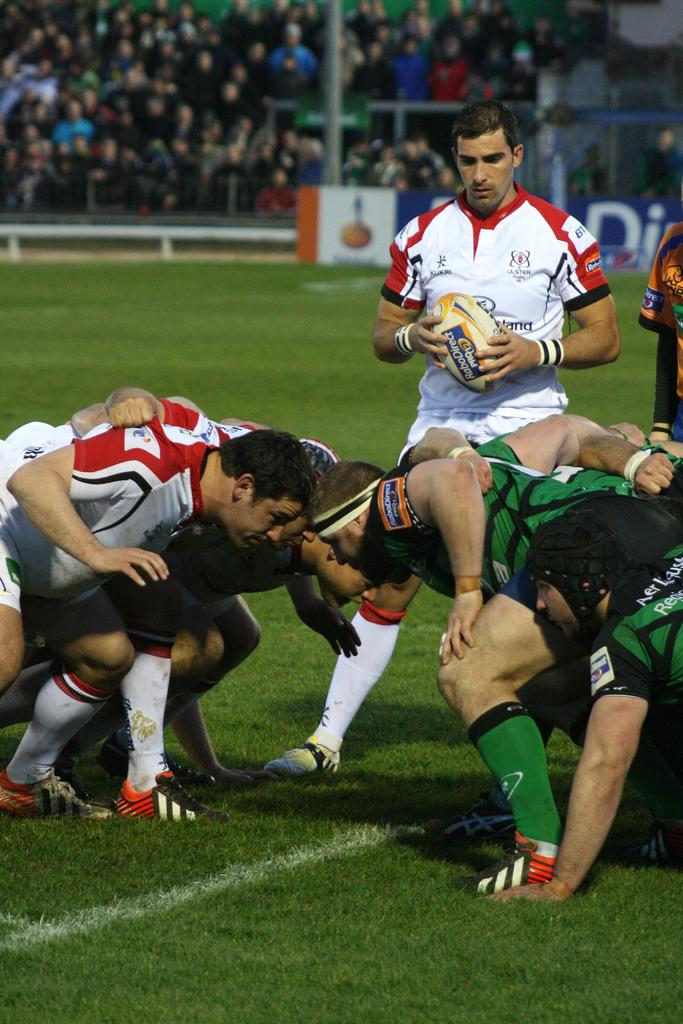How many people are in the image? There are people present in the image. Where are the people located? The people are in a ground. Can you describe the person in the center of the image? The person in the center is standing and holding a ball. What can be seen in the background of the image? There are people and a banner visible in the background of the image. What type of knowledge is being shared among the people in the image? There is no indication in the image that the people are sharing knowledge. Is there a fire visible in the image? No, there is no fire present in the image. 